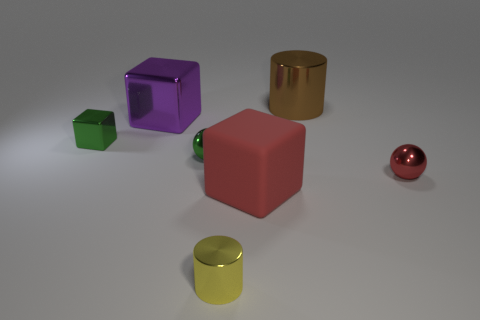How many other objects are there of the same shape as the large matte thing?
Keep it short and to the point. 2. Is the number of metallic cylinders that are behind the small yellow cylinder less than the number of shiny objects in front of the big purple metallic object?
Provide a short and direct response. Yes. Are there any other things that are the same material as the big brown object?
Offer a terse response. Yes. There is a purple thing that is made of the same material as the small green block; what shape is it?
Provide a short and direct response. Cube. Are there any other things that are the same color as the large rubber object?
Provide a succinct answer. Yes. There is a large block behind the tiny green metal object that is in front of the small metal cube; what color is it?
Provide a succinct answer. Purple. There is a cylinder that is behind the metallic cylinder in front of the small shiny sphere that is behind the small red metallic ball; what is its material?
Make the answer very short. Metal. How many green shiny balls are the same size as the red rubber thing?
Provide a short and direct response. 0. What is the material of the thing that is to the right of the small yellow cylinder and behind the small red ball?
Offer a terse response. Metal. How many big matte blocks are on the right side of the small red sphere?
Your answer should be very brief. 0. 